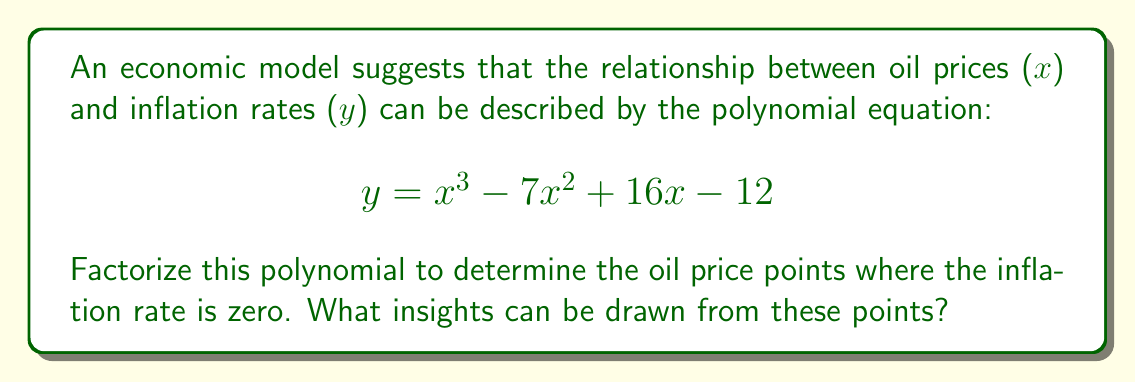Provide a solution to this math problem. To solve this problem, we need to factorize the polynomial $y = x^3 - 7x^2 + 16x - 12$.

Step 1: Identify the equation as a cubic polynomial.
$$ y = x^3 - 7x^2 + 16x - 12 $$

Step 2: Try to factor out the greatest common factor (GCF). In this case, there is no common factor.

Step 3: Use the rational root theorem to find potential roots. The potential rational roots are factors of the constant term (12): ±1, ±2, ±3, ±4, ±6, ±12.

Step 4: Test these potential roots. We find that x = 1 is a root.

Step 5: Use polynomial long division to divide the original polynomial by (x - 1):

$$ \frac{x^3 - 7x^2 + 16x - 12}{x - 1} = x^2 - 6x + 10 $$

Step 6: Factor the resulting quadratic equation:
$$ x^2 - 6x + 10 = (x - 3)(x - 3) = (x - 3)^2 $$

Step 7: Write the fully factored polynomial:
$$ y = (x - 1)(x - 3)^2 $$

Therefore, the oil price points where the inflation rate is zero are x = 1 and x = 3 (with x = 3 being a double root).

Insights:
1. When the oil price is 1 unit, the inflation rate is zero.
2. When the oil price is 3 units, the inflation rate is zero and changes from negative to positive (or vice versa) due to the double root.
3. The model suggests that there are two critical oil price points where inflation is neutralized.
4. The double root at x = 3 indicates a more stable equilibrium point, as small changes around this price are less likely to affect inflation dramatically.
Answer: $y = (x - 1)(x - 3)^2$; Critical oil prices: 1 and 3 units 